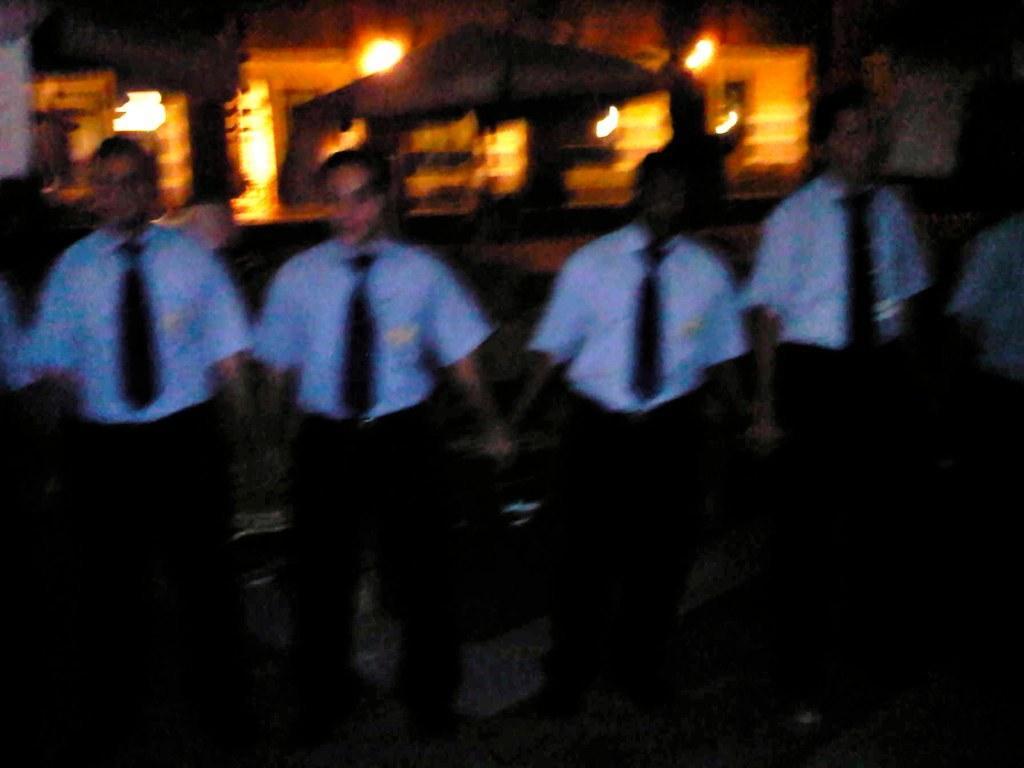Please provide a concise description of this image. In this picture, we can see a group of people standing on the path in dark. Behind the people, there are blurred items. 